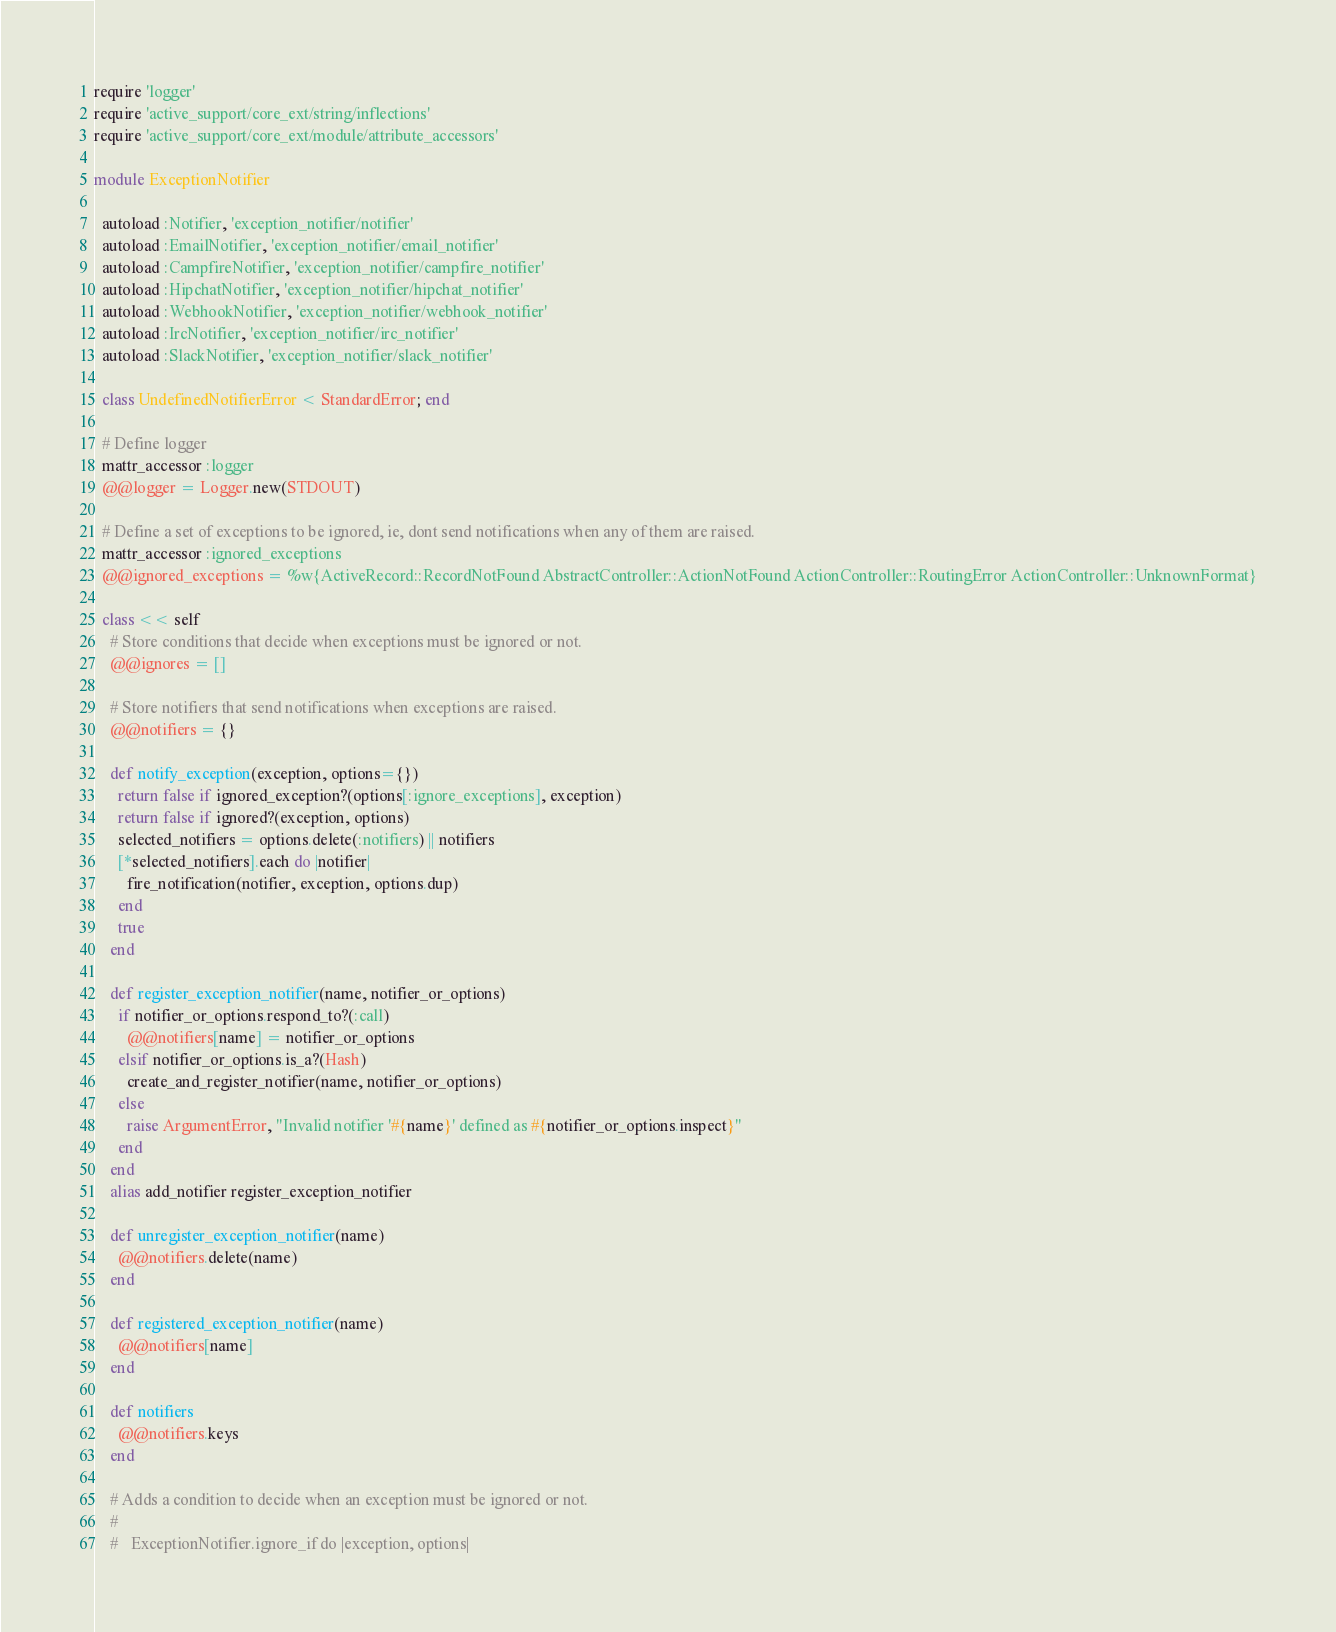<code> <loc_0><loc_0><loc_500><loc_500><_Ruby_>require 'logger'
require 'active_support/core_ext/string/inflections'
require 'active_support/core_ext/module/attribute_accessors'

module ExceptionNotifier

  autoload :Notifier, 'exception_notifier/notifier'
  autoload :EmailNotifier, 'exception_notifier/email_notifier'
  autoload :CampfireNotifier, 'exception_notifier/campfire_notifier'
  autoload :HipchatNotifier, 'exception_notifier/hipchat_notifier'
  autoload :WebhookNotifier, 'exception_notifier/webhook_notifier'
  autoload :IrcNotifier, 'exception_notifier/irc_notifier'
  autoload :SlackNotifier, 'exception_notifier/slack_notifier'

  class UndefinedNotifierError < StandardError; end

  # Define logger
  mattr_accessor :logger
  @@logger = Logger.new(STDOUT)

  # Define a set of exceptions to be ignored, ie, dont send notifications when any of them are raised.
  mattr_accessor :ignored_exceptions
  @@ignored_exceptions = %w{ActiveRecord::RecordNotFound AbstractController::ActionNotFound ActionController::RoutingError ActionController::UnknownFormat}

  class << self
    # Store conditions that decide when exceptions must be ignored or not.
    @@ignores = []

    # Store notifiers that send notifications when exceptions are raised.
    @@notifiers = {}

    def notify_exception(exception, options={})
      return false if ignored_exception?(options[:ignore_exceptions], exception)
      return false if ignored?(exception, options)
      selected_notifiers = options.delete(:notifiers) || notifiers
      [*selected_notifiers].each do |notifier|
        fire_notification(notifier, exception, options.dup)
      end
      true
    end

    def register_exception_notifier(name, notifier_or_options)
      if notifier_or_options.respond_to?(:call)
        @@notifiers[name] = notifier_or_options
      elsif notifier_or_options.is_a?(Hash)
        create_and_register_notifier(name, notifier_or_options)
      else
        raise ArgumentError, "Invalid notifier '#{name}' defined as #{notifier_or_options.inspect}"
      end
    end
    alias add_notifier register_exception_notifier

    def unregister_exception_notifier(name)
      @@notifiers.delete(name)
    end

    def registered_exception_notifier(name)
      @@notifiers[name]
    end

    def notifiers
      @@notifiers.keys
    end

    # Adds a condition to decide when an exception must be ignored or not.
    #
    #   ExceptionNotifier.ignore_if do |exception, options|</code> 